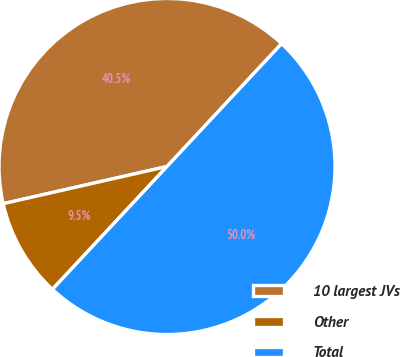<chart> <loc_0><loc_0><loc_500><loc_500><pie_chart><fcel>10 largest JVs<fcel>Other<fcel>Total<nl><fcel>40.5%<fcel>9.5%<fcel>50.0%<nl></chart> 